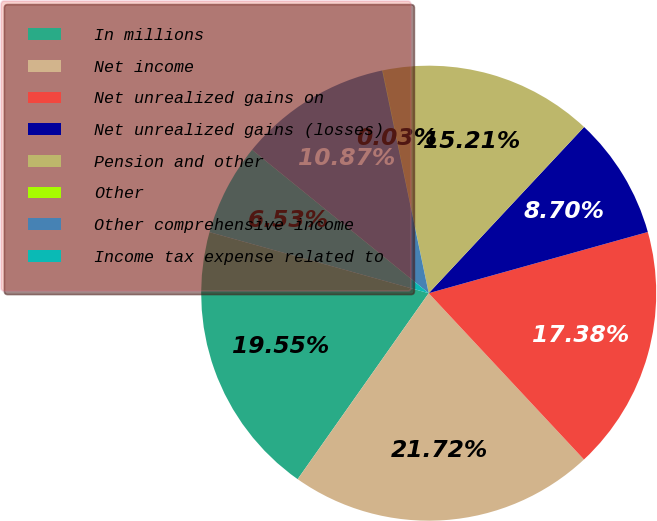<chart> <loc_0><loc_0><loc_500><loc_500><pie_chart><fcel>In millions<fcel>Net income<fcel>Net unrealized gains on<fcel>Net unrealized gains (losses)<fcel>Pension and other<fcel>Other<fcel>Other comprehensive income<fcel>Income tax expense related to<nl><fcel>19.55%<fcel>21.72%<fcel>17.38%<fcel>8.7%<fcel>15.21%<fcel>0.03%<fcel>10.87%<fcel>6.53%<nl></chart> 